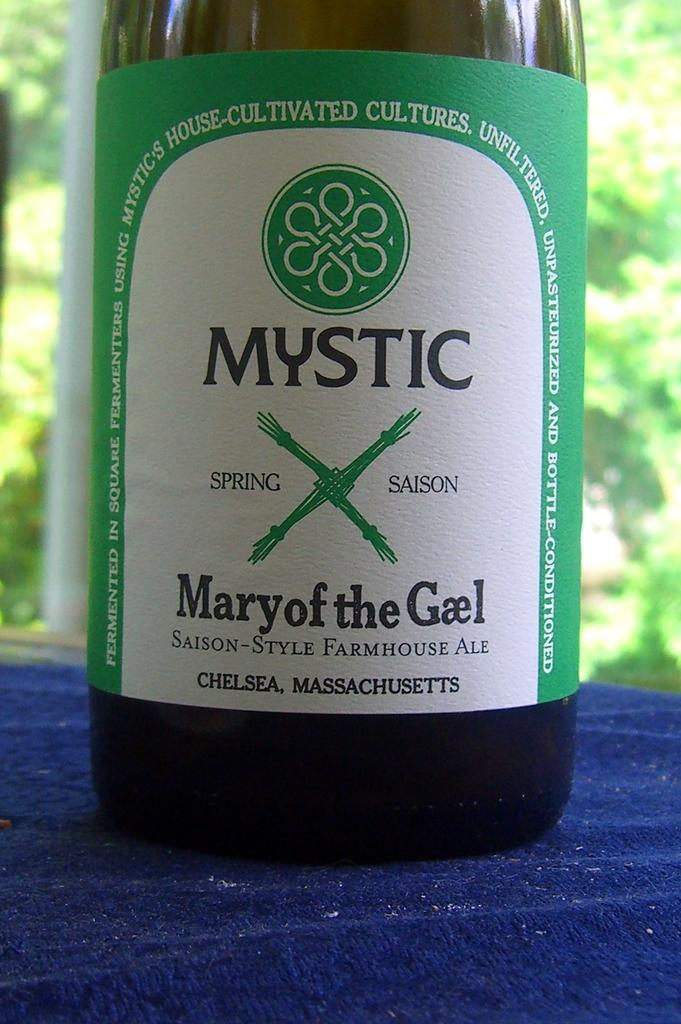Provide a one-sentence caption for the provided image. A bottle of ale, labelled Mystic Mary of the Gael, is made in Chelsea, Massachusetts. 